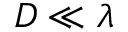<formula> <loc_0><loc_0><loc_500><loc_500>D \ll \lambda</formula> 